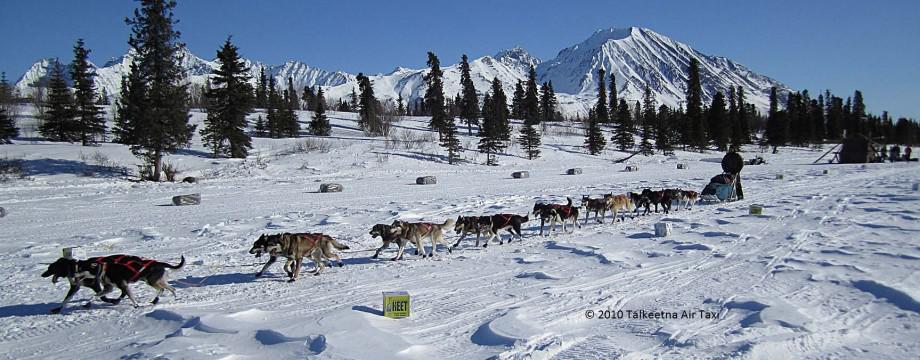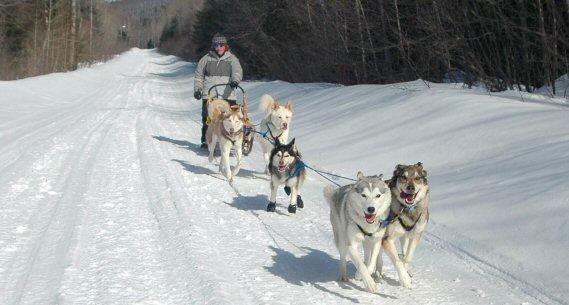The first image is the image on the left, the second image is the image on the right. Assess this claim about the two images: "In one image, a fraction of the dogs in a sled team headed toward the camera are wearing black booties.". Correct or not? Answer yes or no. Yes. 